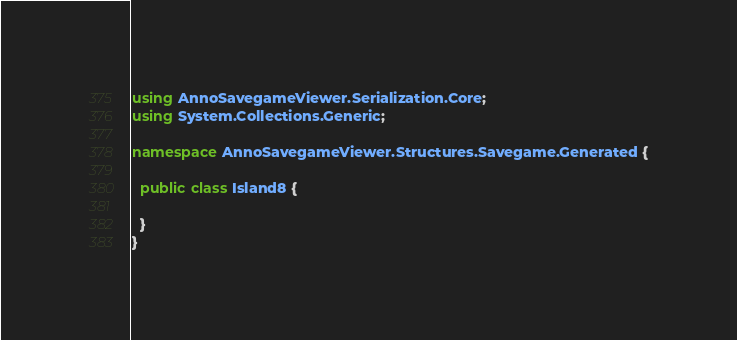Convert code to text. <code><loc_0><loc_0><loc_500><loc_500><_C#_>using AnnoSavegameViewer.Serialization.Core;
using System.Collections.Generic;

namespace AnnoSavegameViewer.Structures.Savegame.Generated {

  public class Island8 {

  }
}</code> 